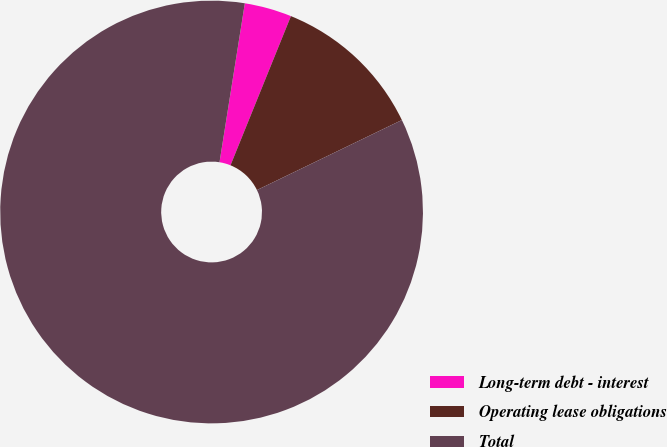<chart> <loc_0><loc_0><loc_500><loc_500><pie_chart><fcel>Long-term debt - interest<fcel>Operating lease obligations<fcel>Total<nl><fcel>3.61%<fcel>11.71%<fcel>84.68%<nl></chart> 